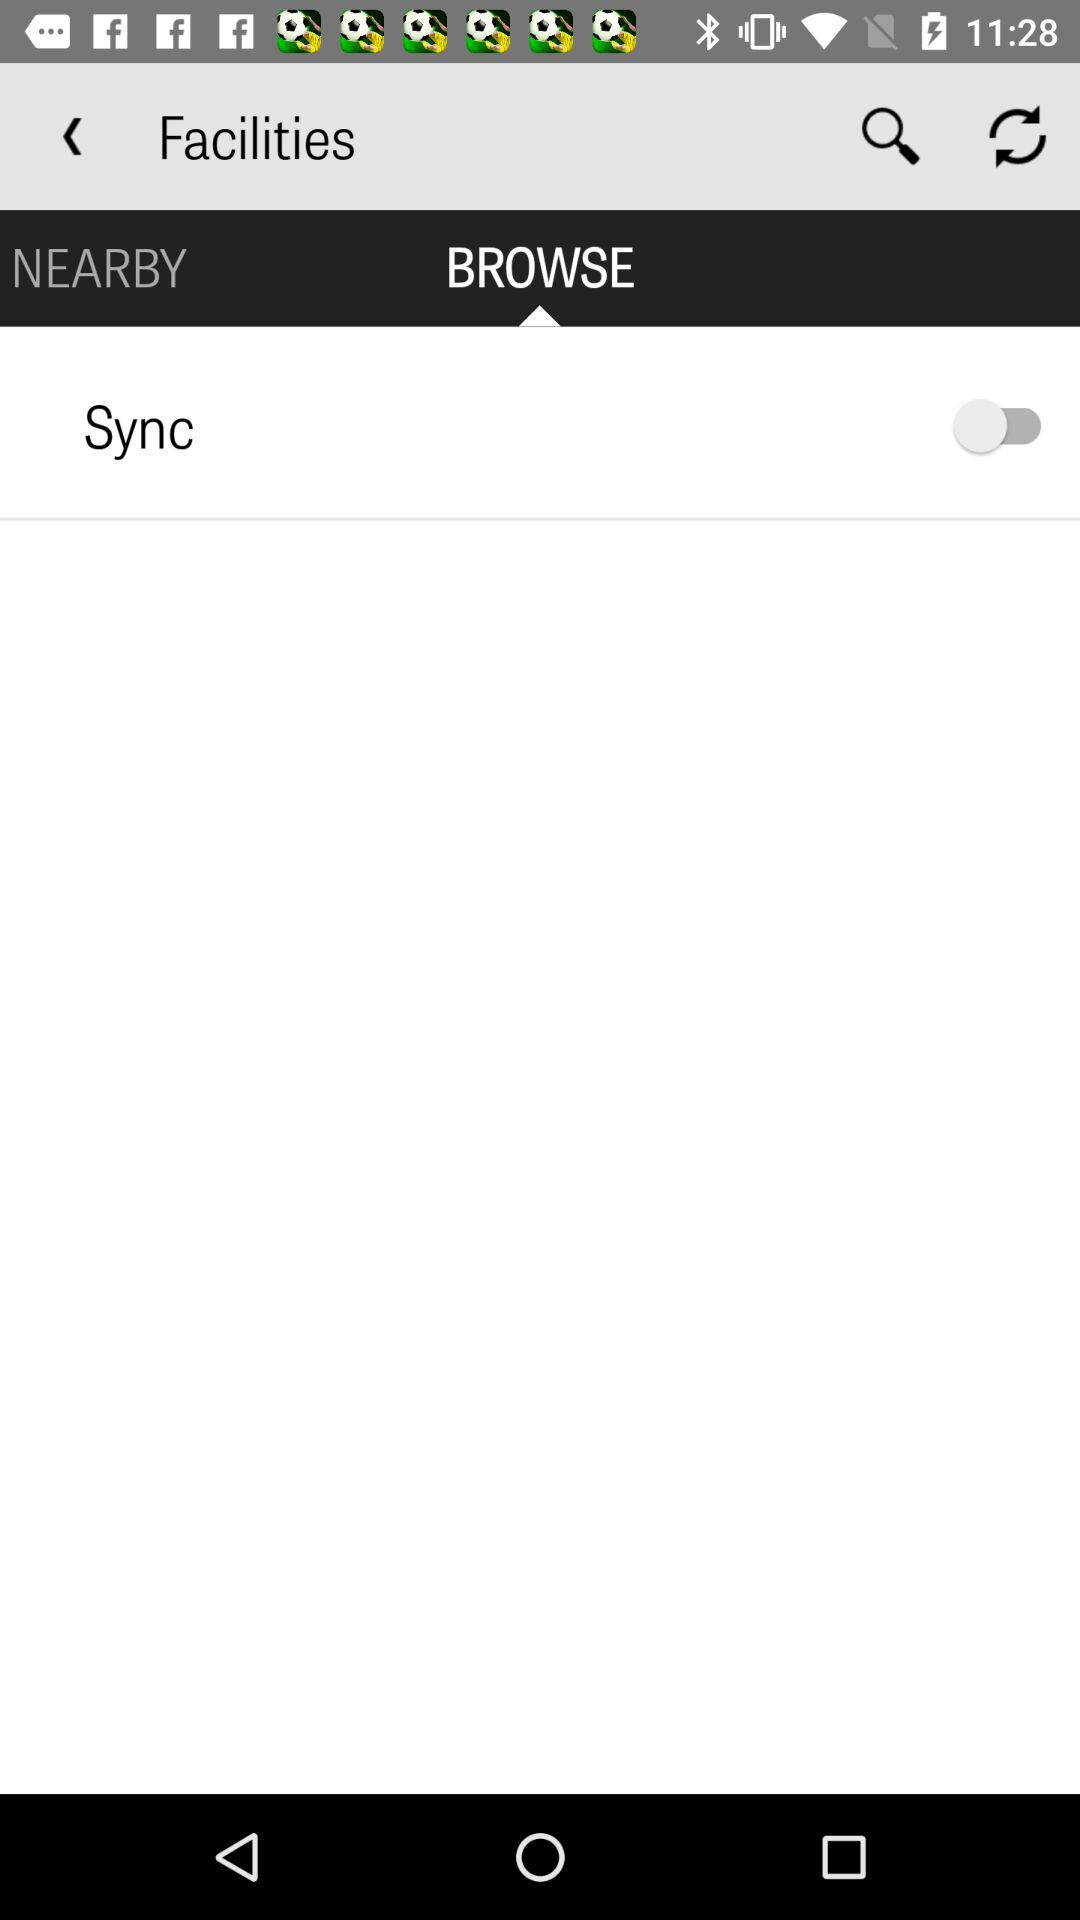What is the status of "Sync"? The status is "off". 